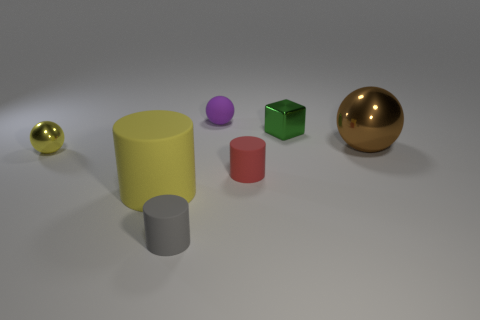Is the color of the small metallic ball the same as the large cylinder?
Your answer should be very brief. Yes. How many blue objects are either tiny balls or rubber balls?
Your answer should be very brief. 0. What is the material of the thing behind the small metal cube?
Keep it short and to the point. Rubber. Are there more tiny rubber spheres than small yellow matte cubes?
Keep it short and to the point. Yes. Do the tiny object that is to the left of the large matte object and the red matte object have the same shape?
Give a very brief answer. No. What number of tiny objects are on the right side of the small yellow shiny sphere and in front of the brown metallic sphere?
Provide a succinct answer. 2. How many yellow things have the same shape as the small red rubber object?
Give a very brief answer. 1. There is a small metallic sphere in front of the purple matte object behind the tiny green thing; what color is it?
Make the answer very short. Yellow. Is the shape of the large brown object the same as the metal thing that is left of the purple rubber thing?
Ensure brevity in your answer.  Yes. There is a yellow thing on the right side of the tiny ball left of the rubber object that is on the left side of the tiny gray matte cylinder; what is it made of?
Make the answer very short. Rubber. 